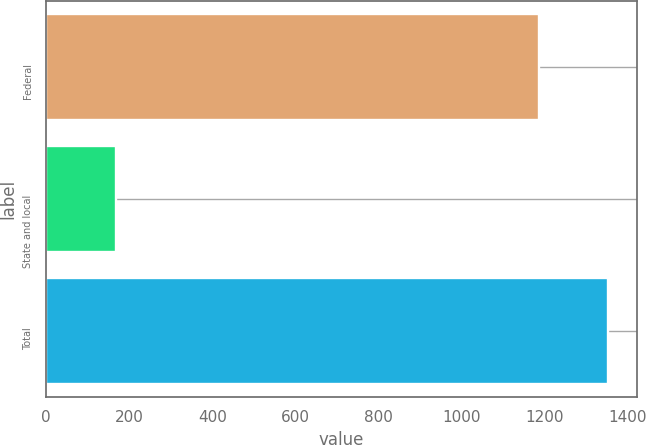Convert chart. <chart><loc_0><loc_0><loc_500><loc_500><bar_chart><fcel>Federal<fcel>State and local<fcel>Total<nl><fcel>1185<fcel>169<fcel>1353<nl></chart> 